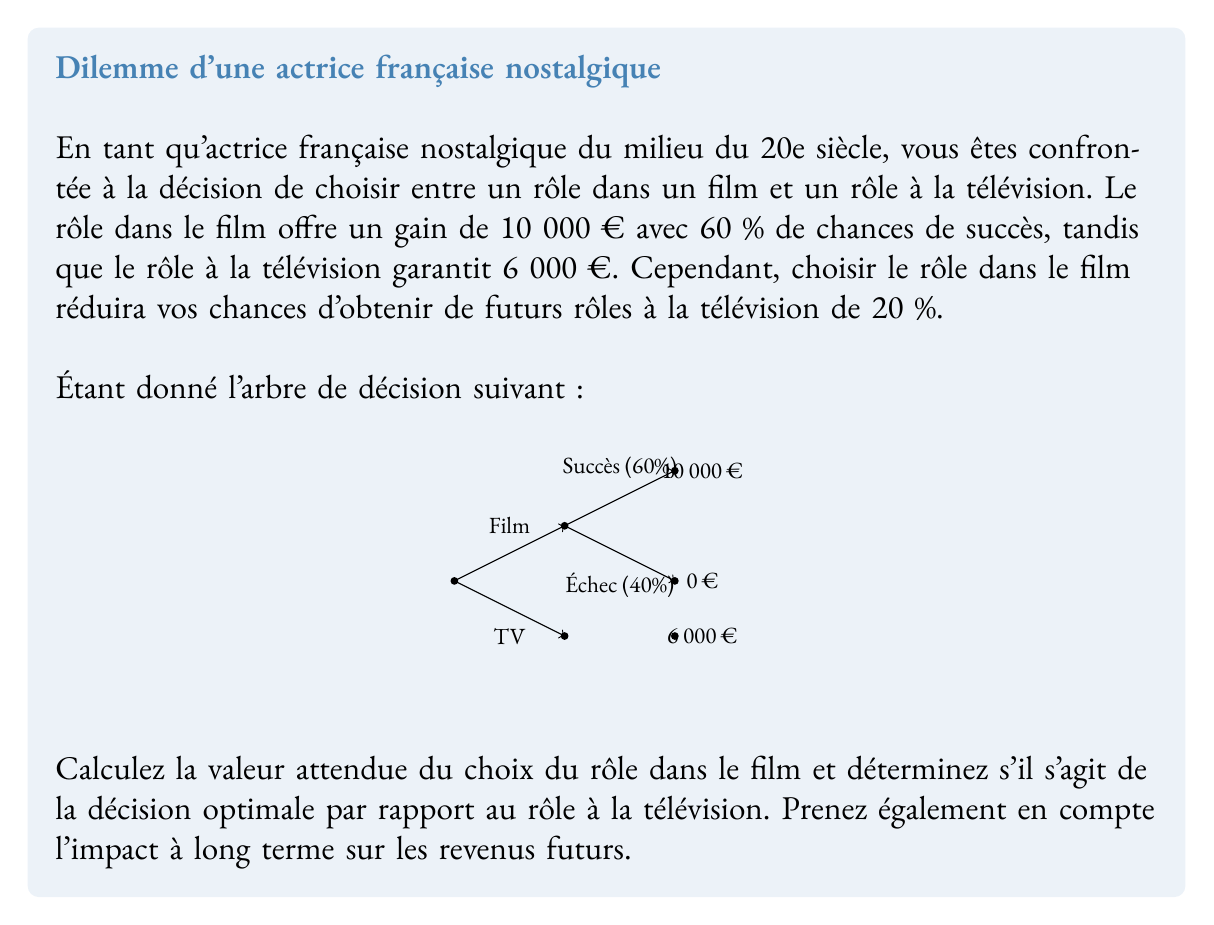Provide a solution to this math problem. Let's approach this problem step-by-step:

1) First, calculate the expected value (EV) of the film role:
   $$EV_{film} = 0.60 \times €10,000 + 0.40 \times €0 = €6,000$$

2) The television role has a guaranteed payoff of €6,000, so:
   $$EV_{TV} = €6,000$$

3) At first glance, the expected values are equal. However, we need to consider the long-term impact on future earnings.

4) Choosing the film role reduces future TV role chances by 20%. Let's assume this impact lasts for one year and you typically do 5 TV roles per year. The potential loss is:
   $$Loss_{future} = 0.20 \times 5 \times €6,000 = €6,000$$

5) Adjusting the expected value of the film role:
   $$EV_{film\_adjusted} = €6,000 - €6,000 = €0$$

6) Compare the adjusted expected values:
   $$EV_{film\_adjusted} = €0 < EV_{TV} = €6,000$$

7) The decision tree can be updated to include this information:

   [asy]
   unitsize(0.8cm);
   draw((0,0)--(2,1),arrow);
   draw((0,0)--(2,-1),arrow);
   draw((2,1)--(4,2),arrow);
   draw((2,1)--(4,0),arrow);
   label("Film", (1,0.7));
   label("TV", (1,-0.7));
   label("Success (60%)", (3,1.7));
   label("Failure (40%)", (3,0.3));
   label("€10,000 - €6,000 = €4,000", (6,2));
   label("€0 - €6,000 = -€6,000", (5.5,0));
   label("€6,000", (4.5,-1));
   dot((0,0));
   dot((2,1));
   dot((2,-1));
   dot((4,2));
   dot((4,0));
   dot((4,-1));
   [/asy]
Answer: Choose the television role (€6,000 > €0). 